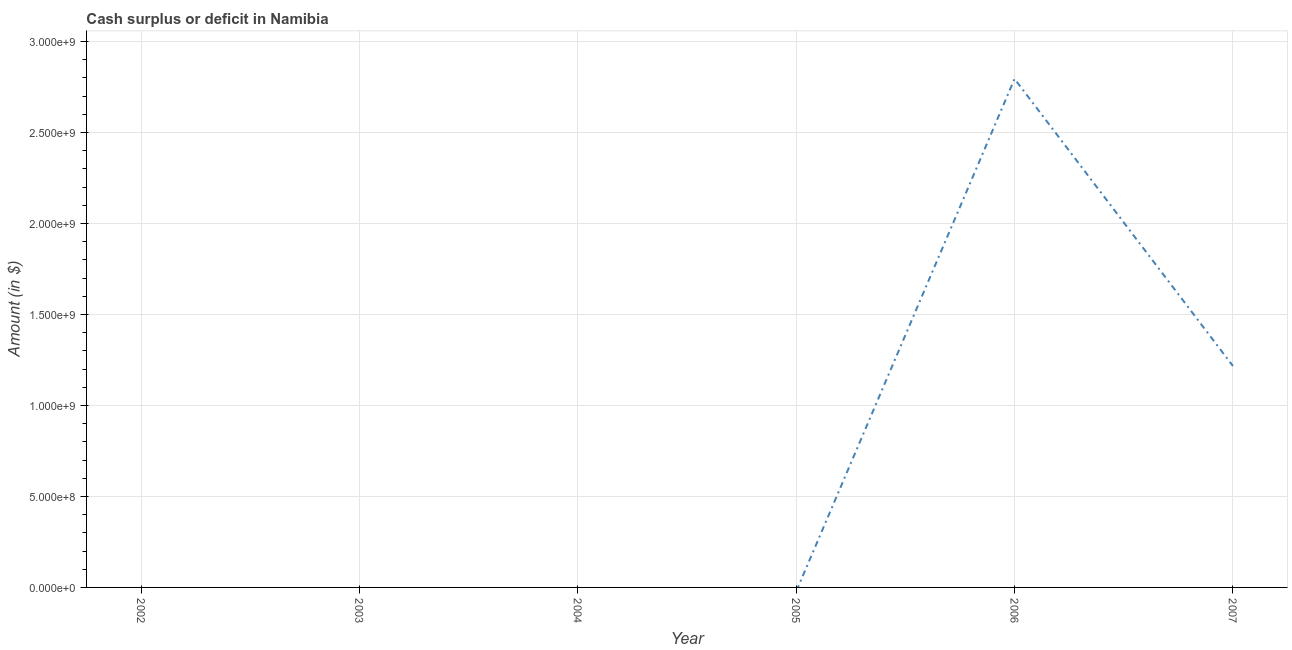What is the cash surplus or deficit in 2003?
Make the answer very short. 0. Across all years, what is the maximum cash surplus or deficit?
Offer a terse response. 2.79e+09. In which year was the cash surplus or deficit maximum?
Keep it short and to the point. 2006. What is the sum of the cash surplus or deficit?
Offer a very short reply. 4.01e+09. What is the difference between the cash surplus or deficit in 2006 and 2007?
Your answer should be very brief. 1.58e+09. What is the average cash surplus or deficit per year?
Your response must be concise. 6.69e+08. What is the median cash surplus or deficit?
Offer a terse response. 0. In how many years, is the cash surplus or deficit greater than 700000000 $?
Ensure brevity in your answer.  2. What is the difference between the highest and the lowest cash surplus or deficit?
Provide a short and direct response. 2.79e+09. In how many years, is the cash surplus or deficit greater than the average cash surplus or deficit taken over all years?
Ensure brevity in your answer.  2. Does the cash surplus or deficit monotonically increase over the years?
Offer a terse response. No. How many years are there in the graph?
Your answer should be compact. 6. Are the values on the major ticks of Y-axis written in scientific E-notation?
Your response must be concise. Yes. Does the graph contain any zero values?
Give a very brief answer. Yes. Does the graph contain grids?
Ensure brevity in your answer.  Yes. What is the title of the graph?
Your answer should be very brief. Cash surplus or deficit in Namibia. What is the label or title of the X-axis?
Provide a succinct answer. Year. What is the label or title of the Y-axis?
Give a very brief answer. Amount (in $). What is the Amount (in $) of 2002?
Your answer should be compact. 0. What is the Amount (in $) of 2003?
Give a very brief answer. 0. What is the Amount (in $) of 2004?
Your response must be concise. 0. What is the Amount (in $) in 2005?
Your answer should be very brief. 0. What is the Amount (in $) in 2006?
Your response must be concise. 2.79e+09. What is the Amount (in $) of 2007?
Your response must be concise. 1.22e+09. What is the difference between the Amount (in $) in 2006 and 2007?
Offer a terse response. 1.58e+09. What is the ratio of the Amount (in $) in 2006 to that in 2007?
Your answer should be compact. 2.3. 